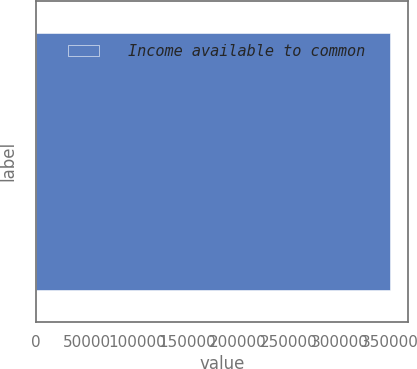<chart> <loc_0><loc_0><loc_500><loc_500><bar_chart><fcel>Income available to common<nl><fcel>350386<nl></chart> 